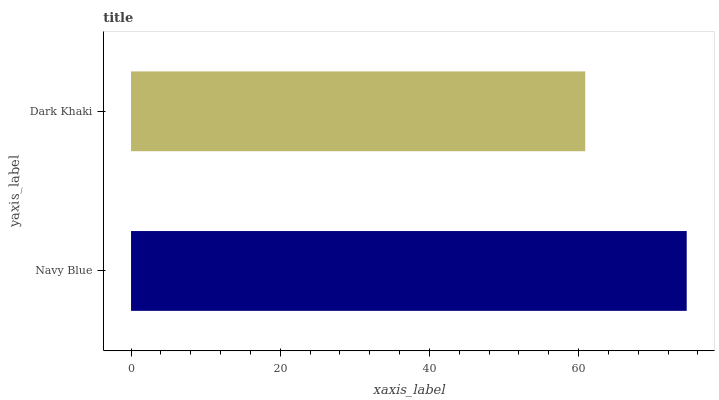Is Dark Khaki the minimum?
Answer yes or no. Yes. Is Navy Blue the maximum?
Answer yes or no. Yes. Is Dark Khaki the maximum?
Answer yes or no. No. Is Navy Blue greater than Dark Khaki?
Answer yes or no. Yes. Is Dark Khaki less than Navy Blue?
Answer yes or no. Yes. Is Dark Khaki greater than Navy Blue?
Answer yes or no. No. Is Navy Blue less than Dark Khaki?
Answer yes or no. No. Is Navy Blue the high median?
Answer yes or no. Yes. Is Dark Khaki the low median?
Answer yes or no. Yes. Is Dark Khaki the high median?
Answer yes or no. No. Is Navy Blue the low median?
Answer yes or no. No. 